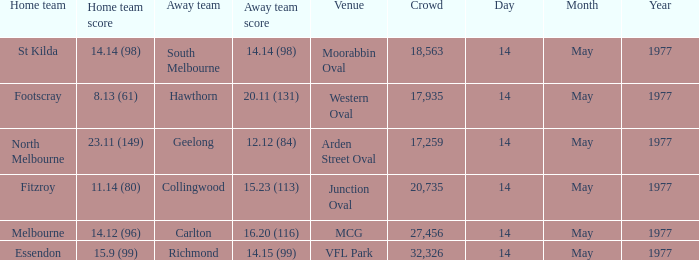When collingwood was the visiting team, how many people were present in the crowd? 1.0. 